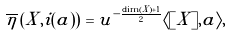<formula> <loc_0><loc_0><loc_500><loc_500>\overline { \eta } \left ( X , i ( a ) \right ) = u ^ { - \frac { \dim ( X ) + 1 } { 2 } } \langle [ X ] , a \rangle ,</formula> 